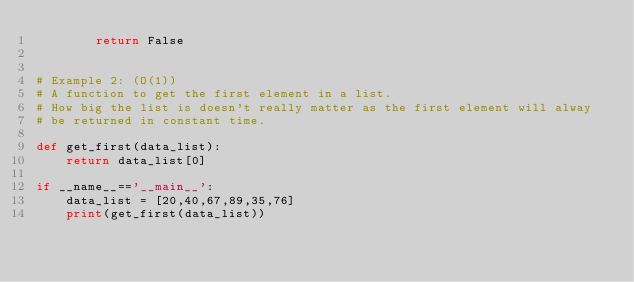<code> <loc_0><loc_0><loc_500><loc_500><_Python_>        return False


# Example 2: (O(1))
# A function to get the first element in a list.
# How big the list is doesn't really matter as the first element will alway
# be returned in constant time.

def get_first(data_list):
    return data_list[0]

if __name__=='__main__':
    data_list = [20,40,67,89,35,76]
    print(get_first(data_list))
</code> 